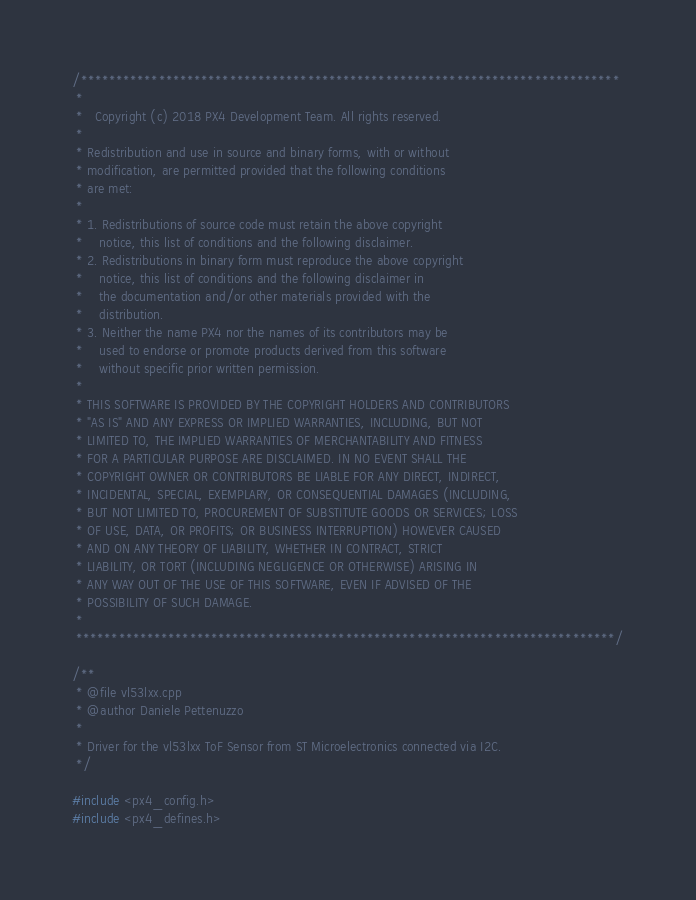<code> <loc_0><loc_0><loc_500><loc_500><_C++_>/****************************************************************************
 *
 *   Copyright (c) 2018 PX4 Development Team. All rights reserved.
 *
 * Redistribution and use in source and binary forms, with or without
 * modification, are permitted provided that the following conditions
 * are met:
 *
 * 1. Redistributions of source code must retain the above copyright
 *    notice, this list of conditions and the following disclaimer.
 * 2. Redistributions in binary form must reproduce the above copyright
 *    notice, this list of conditions and the following disclaimer in
 *    the documentation and/or other materials provided with the
 *    distribution.
 * 3. Neither the name PX4 nor the names of its contributors may be
 *    used to endorse or promote products derived from this software
 *    without specific prior written permission.
 *
 * THIS SOFTWARE IS PROVIDED BY THE COPYRIGHT HOLDERS AND CONTRIBUTORS
 * "AS IS" AND ANY EXPRESS OR IMPLIED WARRANTIES, INCLUDING, BUT NOT
 * LIMITED TO, THE IMPLIED WARRANTIES OF MERCHANTABILITY AND FITNESS
 * FOR A PARTICULAR PURPOSE ARE DISCLAIMED. IN NO EVENT SHALL THE
 * COPYRIGHT OWNER OR CONTRIBUTORS BE LIABLE FOR ANY DIRECT, INDIRECT,
 * INCIDENTAL, SPECIAL, EXEMPLARY, OR CONSEQUENTIAL DAMAGES (INCLUDING,
 * BUT NOT LIMITED TO, PROCUREMENT OF SUBSTITUTE GOODS OR SERVICES; LOSS
 * OF USE, DATA, OR PROFITS; OR BUSINESS INTERRUPTION) HOWEVER CAUSED
 * AND ON ANY THEORY OF LIABILITY, WHETHER IN CONTRACT, STRICT
 * LIABILITY, OR TORT (INCLUDING NEGLIGENCE OR OTHERWISE) ARISING IN
 * ANY WAY OUT OF THE USE OF THIS SOFTWARE, EVEN IF ADVISED OF THE
 * POSSIBILITY OF SUCH DAMAGE.
 *
 ****************************************************************************/

/**
 * @file vl53lxx.cpp
 * @author Daniele Pettenuzzo
 *
 * Driver for the vl53lxx ToF Sensor from ST Microelectronics connected via I2C.
 */

#include <px4_config.h>
#include <px4_defines.h></code> 